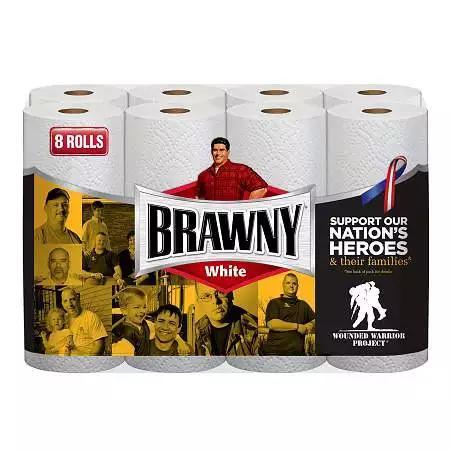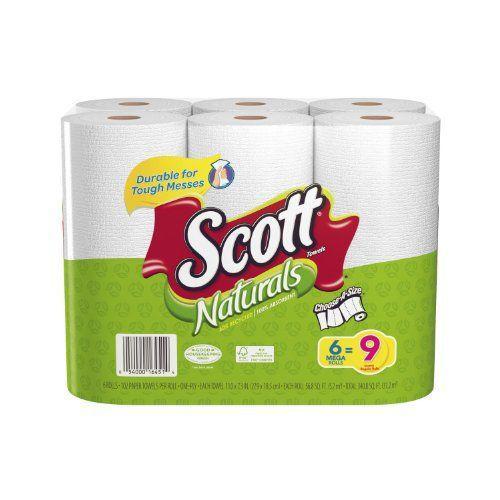The first image is the image on the left, the second image is the image on the right. Given the left and right images, does the statement "The left image contains at least six rolls of paper towels." hold true? Answer yes or no. Yes. The first image is the image on the left, the second image is the image on the right. Considering the images on both sides, is "The paper towel packaging on the left depicts a man in a red flannel shirt, but the paper towel packaging on the right does not." valid? Answer yes or no. Yes. 